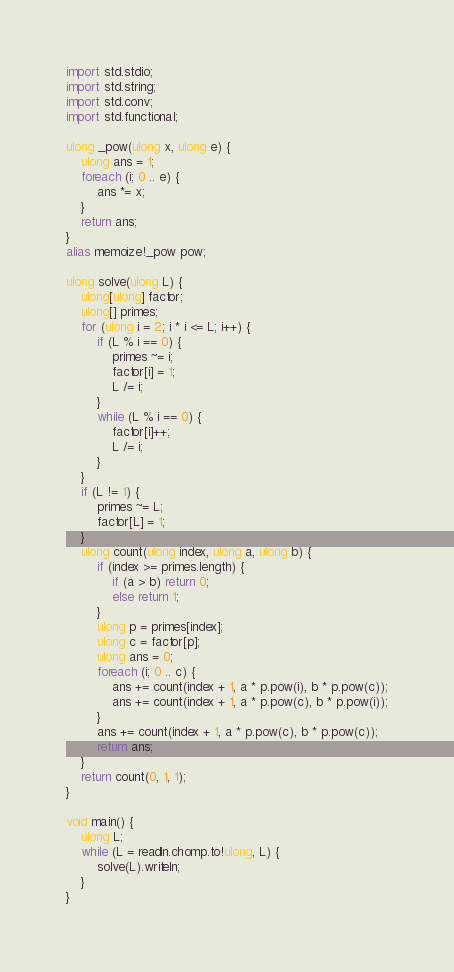<code> <loc_0><loc_0><loc_500><loc_500><_D_>import std.stdio;
import std.string;
import std.conv;
import std.functional;

ulong _pow(ulong x, ulong e) {
    ulong ans = 1;
    foreach (i; 0 .. e) {
        ans *= x;
    }
    return ans;
}
alias memoize!_pow pow;

ulong solve(ulong L) {
    ulong[ulong] factor;
    ulong[] primes;
    for (ulong i = 2; i * i <= L; i++) {
        if (L % i == 0) {
            primes ~= i;
            factor[i] = 1;
            L /= i;
        }
        while (L % i == 0) {
            factor[i]++;
            L /= i;
        }
    }
    if (L != 1) {
        primes ~= L;
        factor[L] = 1;
    }
    ulong count(ulong index, ulong a, ulong b) {
        if (index >= primes.length) {
            if (a > b) return 0;
            else return 1;
        }
        ulong p = primes[index];
        ulong c = factor[p];
        ulong ans = 0;
        foreach (i; 0 .. c) {
            ans += count(index + 1, a * p.pow(i), b * p.pow(c));
            ans += count(index + 1, a * p.pow(c), b * p.pow(i));
        }
        ans += count(index + 1, a * p.pow(c), b * p.pow(c));
        return ans;
    }
    return count(0, 1, 1);
}

void main() {
    ulong L;
    while (L = readln.chomp.to!ulong, L) {
        solve(L).writeln;
    }
}</code> 